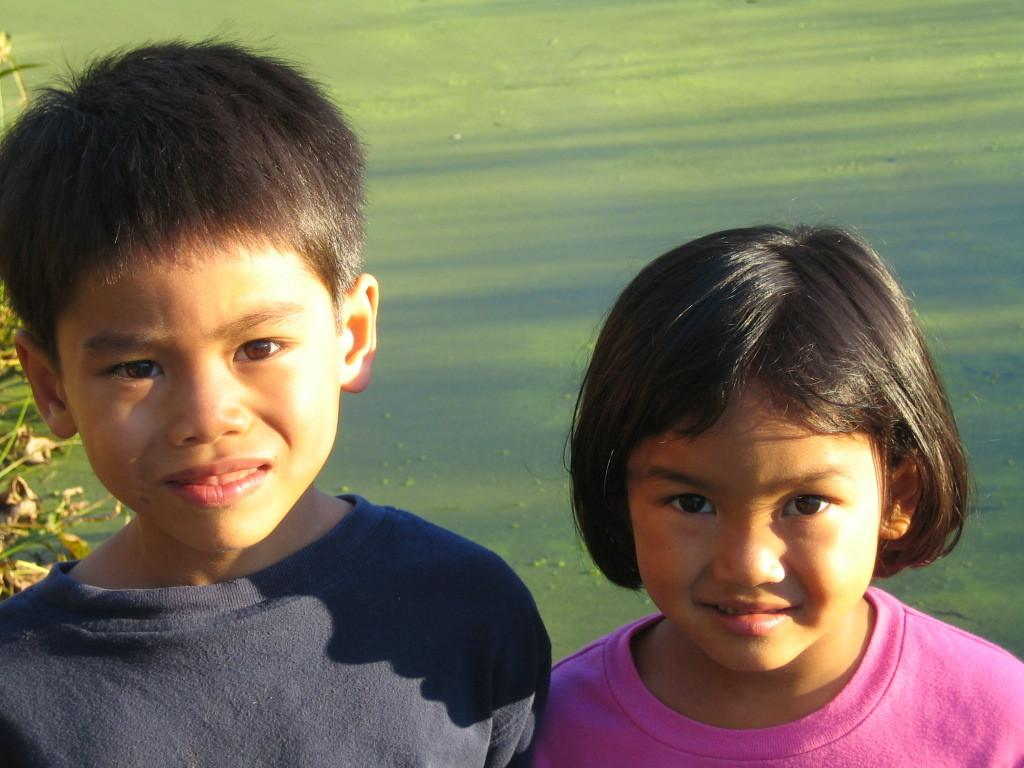How many kids are in the picture? There are two kids in the picture. What is the background behind the kids? There is a green surface behind the kids. How is the sunlight affecting the kids in the picture? Sun rays are falling on the faces of the kids. What type of cough medicine is the kid holding in the picture? There is no cough medicine or any indication of a cough in the picture; it features two kids with sun rays falling on their faces. 